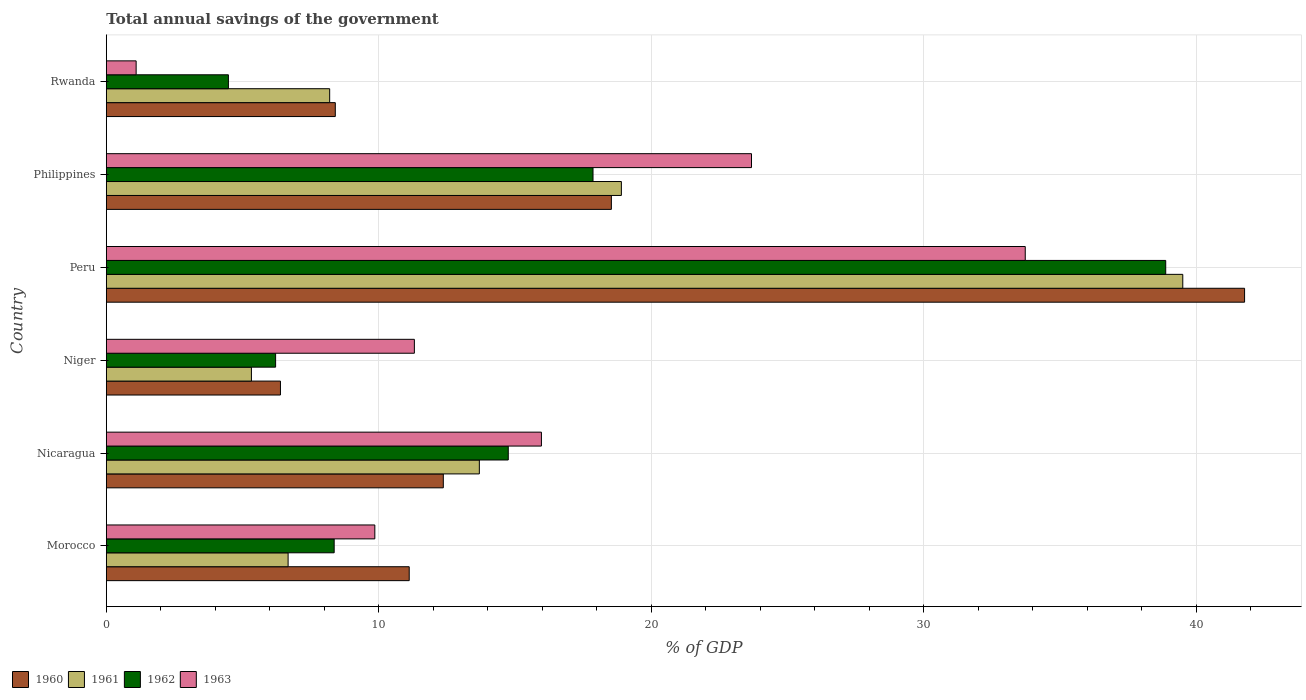How many different coloured bars are there?
Ensure brevity in your answer.  4. How many groups of bars are there?
Ensure brevity in your answer.  6. Are the number of bars per tick equal to the number of legend labels?
Give a very brief answer. Yes. Are the number of bars on each tick of the Y-axis equal?
Make the answer very short. Yes. How many bars are there on the 5th tick from the bottom?
Provide a succinct answer. 4. What is the label of the 5th group of bars from the top?
Your answer should be compact. Nicaragua. What is the total annual savings of the government in 1963 in Philippines?
Ensure brevity in your answer.  23.68. Across all countries, what is the maximum total annual savings of the government in 1960?
Offer a terse response. 41.78. Across all countries, what is the minimum total annual savings of the government in 1960?
Provide a short and direct response. 6.39. In which country was the total annual savings of the government in 1962 maximum?
Ensure brevity in your answer.  Peru. In which country was the total annual savings of the government in 1962 minimum?
Provide a short and direct response. Rwanda. What is the total total annual savings of the government in 1961 in the graph?
Your response must be concise. 92.29. What is the difference between the total annual savings of the government in 1962 in Peru and that in Philippines?
Give a very brief answer. 21.02. What is the difference between the total annual savings of the government in 1960 in Rwanda and the total annual savings of the government in 1963 in Nicaragua?
Provide a succinct answer. -7.56. What is the average total annual savings of the government in 1961 per country?
Your answer should be compact. 15.38. What is the difference between the total annual savings of the government in 1962 and total annual savings of the government in 1963 in Nicaragua?
Offer a very short reply. -1.22. In how many countries, is the total annual savings of the government in 1963 greater than 18 %?
Your response must be concise. 2. What is the ratio of the total annual savings of the government in 1960 in Peru to that in Rwanda?
Provide a succinct answer. 4.97. What is the difference between the highest and the second highest total annual savings of the government in 1960?
Provide a short and direct response. 23.24. What is the difference between the highest and the lowest total annual savings of the government in 1961?
Your answer should be very brief. 34.18. Is the sum of the total annual savings of the government in 1960 in Peru and Philippines greater than the maximum total annual savings of the government in 1962 across all countries?
Your answer should be very brief. Yes. Is it the case that in every country, the sum of the total annual savings of the government in 1962 and total annual savings of the government in 1961 is greater than the sum of total annual savings of the government in 1963 and total annual savings of the government in 1960?
Make the answer very short. No. What does the 3rd bar from the top in Niger represents?
Your answer should be compact. 1961. How many bars are there?
Offer a terse response. 24. How many countries are there in the graph?
Ensure brevity in your answer.  6. What is the difference between two consecutive major ticks on the X-axis?
Keep it short and to the point. 10. Are the values on the major ticks of X-axis written in scientific E-notation?
Give a very brief answer. No. Does the graph contain any zero values?
Make the answer very short. No. Where does the legend appear in the graph?
Offer a terse response. Bottom left. How many legend labels are there?
Keep it short and to the point. 4. How are the legend labels stacked?
Offer a very short reply. Horizontal. What is the title of the graph?
Your answer should be very brief. Total annual savings of the government. What is the label or title of the X-axis?
Provide a succinct answer. % of GDP. What is the % of GDP in 1960 in Morocco?
Give a very brief answer. 11.12. What is the % of GDP in 1961 in Morocco?
Your response must be concise. 6.67. What is the % of GDP of 1962 in Morocco?
Offer a very short reply. 8.36. What is the % of GDP in 1963 in Morocco?
Ensure brevity in your answer.  9.85. What is the % of GDP of 1960 in Nicaragua?
Offer a terse response. 12.37. What is the % of GDP in 1961 in Nicaragua?
Offer a terse response. 13.69. What is the % of GDP in 1962 in Nicaragua?
Your answer should be compact. 14.75. What is the % of GDP in 1963 in Nicaragua?
Ensure brevity in your answer.  15.97. What is the % of GDP in 1960 in Niger?
Provide a succinct answer. 6.39. What is the % of GDP in 1961 in Niger?
Ensure brevity in your answer.  5.32. What is the % of GDP of 1962 in Niger?
Give a very brief answer. 6.21. What is the % of GDP in 1963 in Niger?
Give a very brief answer. 11.31. What is the % of GDP in 1960 in Peru?
Provide a short and direct response. 41.78. What is the % of GDP of 1961 in Peru?
Your answer should be compact. 39.51. What is the % of GDP in 1962 in Peru?
Your answer should be compact. 38.88. What is the % of GDP in 1963 in Peru?
Your answer should be very brief. 33.73. What is the % of GDP in 1960 in Philippines?
Offer a terse response. 18.54. What is the % of GDP in 1961 in Philippines?
Offer a terse response. 18.9. What is the % of GDP of 1962 in Philippines?
Provide a short and direct response. 17.86. What is the % of GDP in 1963 in Philippines?
Provide a succinct answer. 23.68. What is the % of GDP in 1960 in Rwanda?
Your response must be concise. 8.4. What is the % of GDP of 1961 in Rwanda?
Keep it short and to the point. 8.2. What is the % of GDP of 1962 in Rwanda?
Offer a terse response. 4.48. What is the % of GDP of 1963 in Rwanda?
Provide a short and direct response. 1.09. Across all countries, what is the maximum % of GDP in 1960?
Provide a succinct answer. 41.78. Across all countries, what is the maximum % of GDP in 1961?
Provide a short and direct response. 39.51. Across all countries, what is the maximum % of GDP in 1962?
Provide a short and direct response. 38.88. Across all countries, what is the maximum % of GDP in 1963?
Keep it short and to the point. 33.73. Across all countries, what is the minimum % of GDP in 1960?
Your answer should be compact. 6.39. Across all countries, what is the minimum % of GDP in 1961?
Your response must be concise. 5.32. Across all countries, what is the minimum % of GDP in 1962?
Give a very brief answer. 4.48. Across all countries, what is the minimum % of GDP in 1963?
Provide a succinct answer. 1.09. What is the total % of GDP of 1960 in the graph?
Offer a very short reply. 98.59. What is the total % of GDP of 1961 in the graph?
Ensure brevity in your answer.  92.29. What is the total % of GDP of 1962 in the graph?
Provide a succinct answer. 90.55. What is the total % of GDP in 1963 in the graph?
Give a very brief answer. 95.63. What is the difference between the % of GDP of 1960 in Morocco and that in Nicaragua?
Your answer should be compact. -1.25. What is the difference between the % of GDP of 1961 in Morocco and that in Nicaragua?
Give a very brief answer. -7.02. What is the difference between the % of GDP of 1962 in Morocco and that in Nicaragua?
Offer a very short reply. -6.39. What is the difference between the % of GDP of 1963 in Morocco and that in Nicaragua?
Provide a short and direct response. -6.11. What is the difference between the % of GDP in 1960 in Morocco and that in Niger?
Keep it short and to the point. 4.73. What is the difference between the % of GDP in 1961 in Morocco and that in Niger?
Make the answer very short. 1.35. What is the difference between the % of GDP in 1962 in Morocco and that in Niger?
Keep it short and to the point. 2.15. What is the difference between the % of GDP in 1963 in Morocco and that in Niger?
Offer a terse response. -1.45. What is the difference between the % of GDP in 1960 in Morocco and that in Peru?
Make the answer very short. -30.66. What is the difference between the % of GDP in 1961 in Morocco and that in Peru?
Your answer should be compact. -32.84. What is the difference between the % of GDP of 1962 in Morocco and that in Peru?
Provide a succinct answer. -30.52. What is the difference between the % of GDP in 1963 in Morocco and that in Peru?
Keep it short and to the point. -23.87. What is the difference between the % of GDP of 1960 in Morocco and that in Philippines?
Your answer should be very brief. -7.42. What is the difference between the % of GDP of 1961 in Morocco and that in Philippines?
Keep it short and to the point. -12.23. What is the difference between the % of GDP of 1962 in Morocco and that in Philippines?
Ensure brevity in your answer.  -9.5. What is the difference between the % of GDP in 1963 in Morocco and that in Philippines?
Provide a short and direct response. -13.82. What is the difference between the % of GDP of 1960 in Morocco and that in Rwanda?
Your answer should be very brief. 2.71. What is the difference between the % of GDP of 1961 in Morocco and that in Rwanda?
Your answer should be compact. -1.53. What is the difference between the % of GDP of 1962 in Morocco and that in Rwanda?
Make the answer very short. 3.88. What is the difference between the % of GDP in 1963 in Morocco and that in Rwanda?
Make the answer very short. 8.76. What is the difference between the % of GDP in 1960 in Nicaragua and that in Niger?
Make the answer very short. 5.98. What is the difference between the % of GDP in 1961 in Nicaragua and that in Niger?
Your answer should be compact. 8.37. What is the difference between the % of GDP in 1962 in Nicaragua and that in Niger?
Keep it short and to the point. 8.54. What is the difference between the % of GDP in 1963 in Nicaragua and that in Niger?
Make the answer very short. 4.66. What is the difference between the % of GDP in 1960 in Nicaragua and that in Peru?
Provide a succinct answer. -29.41. What is the difference between the % of GDP of 1961 in Nicaragua and that in Peru?
Provide a succinct answer. -25.82. What is the difference between the % of GDP in 1962 in Nicaragua and that in Peru?
Provide a succinct answer. -24.13. What is the difference between the % of GDP in 1963 in Nicaragua and that in Peru?
Give a very brief answer. -17.76. What is the difference between the % of GDP in 1960 in Nicaragua and that in Philippines?
Give a very brief answer. -6.17. What is the difference between the % of GDP of 1961 in Nicaragua and that in Philippines?
Provide a succinct answer. -5.21. What is the difference between the % of GDP in 1962 in Nicaragua and that in Philippines?
Your answer should be compact. -3.11. What is the difference between the % of GDP of 1963 in Nicaragua and that in Philippines?
Keep it short and to the point. -7.71. What is the difference between the % of GDP of 1960 in Nicaragua and that in Rwanda?
Your response must be concise. 3.96. What is the difference between the % of GDP in 1961 in Nicaragua and that in Rwanda?
Ensure brevity in your answer.  5.49. What is the difference between the % of GDP in 1962 in Nicaragua and that in Rwanda?
Provide a short and direct response. 10.27. What is the difference between the % of GDP of 1963 in Nicaragua and that in Rwanda?
Your answer should be very brief. 14.87. What is the difference between the % of GDP of 1960 in Niger and that in Peru?
Make the answer very short. -35.38. What is the difference between the % of GDP of 1961 in Niger and that in Peru?
Your answer should be compact. -34.18. What is the difference between the % of GDP in 1962 in Niger and that in Peru?
Your answer should be very brief. -32.67. What is the difference between the % of GDP of 1963 in Niger and that in Peru?
Keep it short and to the point. -22.42. What is the difference between the % of GDP of 1960 in Niger and that in Philippines?
Keep it short and to the point. -12.15. What is the difference between the % of GDP of 1961 in Niger and that in Philippines?
Provide a succinct answer. -13.58. What is the difference between the % of GDP of 1962 in Niger and that in Philippines?
Provide a short and direct response. -11.65. What is the difference between the % of GDP in 1963 in Niger and that in Philippines?
Offer a very short reply. -12.37. What is the difference between the % of GDP in 1960 in Niger and that in Rwanda?
Ensure brevity in your answer.  -2.01. What is the difference between the % of GDP of 1961 in Niger and that in Rwanda?
Offer a terse response. -2.87. What is the difference between the % of GDP of 1962 in Niger and that in Rwanda?
Provide a short and direct response. 1.73. What is the difference between the % of GDP of 1963 in Niger and that in Rwanda?
Provide a short and direct response. 10.21. What is the difference between the % of GDP in 1960 in Peru and that in Philippines?
Offer a terse response. 23.24. What is the difference between the % of GDP of 1961 in Peru and that in Philippines?
Your response must be concise. 20.6. What is the difference between the % of GDP in 1962 in Peru and that in Philippines?
Keep it short and to the point. 21.02. What is the difference between the % of GDP of 1963 in Peru and that in Philippines?
Your answer should be compact. 10.05. What is the difference between the % of GDP in 1960 in Peru and that in Rwanda?
Make the answer very short. 33.37. What is the difference between the % of GDP in 1961 in Peru and that in Rwanda?
Give a very brief answer. 31.31. What is the difference between the % of GDP in 1962 in Peru and that in Rwanda?
Provide a succinct answer. 34.4. What is the difference between the % of GDP of 1963 in Peru and that in Rwanda?
Provide a short and direct response. 32.63. What is the difference between the % of GDP in 1960 in Philippines and that in Rwanda?
Your answer should be compact. 10.13. What is the difference between the % of GDP of 1961 in Philippines and that in Rwanda?
Make the answer very short. 10.71. What is the difference between the % of GDP in 1962 in Philippines and that in Rwanda?
Your answer should be very brief. 13.38. What is the difference between the % of GDP of 1963 in Philippines and that in Rwanda?
Your response must be concise. 22.58. What is the difference between the % of GDP of 1960 in Morocco and the % of GDP of 1961 in Nicaragua?
Your answer should be compact. -2.57. What is the difference between the % of GDP of 1960 in Morocco and the % of GDP of 1962 in Nicaragua?
Offer a very short reply. -3.63. What is the difference between the % of GDP of 1960 in Morocco and the % of GDP of 1963 in Nicaragua?
Ensure brevity in your answer.  -4.85. What is the difference between the % of GDP of 1961 in Morocco and the % of GDP of 1962 in Nicaragua?
Ensure brevity in your answer.  -8.08. What is the difference between the % of GDP in 1961 in Morocco and the % of GDP in 1963 in Nicaragua?
Ensure brevity in your answer.  -9.3. What is the difference between the % of GDP in 1962 in Morocco and the % of GDP in 1963 in Nicaragua?
Keep it short and to the point. -7.61. What is the difference between the % of GDP of 1960 in Morocco and the % of GDP of 1961 in Niger?
Provide a succinct answer. 5.79. What is the difference between the % of GDP in 1960 in Morocco and the % of GDP in 1962 in Niger?
Give a very brief answer. 4.9. What is the difference between the % of GDP in 1960 in Morocco and the % of GDP in 1963 in Niger?
Ensure brevity in your answer.  -0.19. What is the difference between the % of GDP in 1961 in Morocco and the % of GDP in 1962 in Niger?
Your response must be concise. 0.46. What is the difference between the % of GDP in 1961 in Morocco and the % of GDP in 1963 in Niger?
Provide a short and direct response. -4.63. What is the difference between the % of GDP in 1962 in Morocco and the % of GDP in 1963 in Niger?
Provide a succinct answer. -2.94. What is the difference between the % of GDP in 1960 in Morocco and the % of GDP in 1961 in Peru?
Offer a terse response. -28.39. What is the difference between the % of GDP of 1960 in Morocco and the % of GDP of 1962 in Peru?
Provide a succinct answer. -27.76. What is the difference between the % of GDP in 1960 in Morocco and the % of GDP in 1963 in Peru?
Your response must be concise. -22.61. What is the difference between the % of GDP in 1961 in Morocco and the % of GDP in 1962 in Peru?
Offer a terse response. -32.21. What is the difference between the % of GDP of 1961 in Morocco and the % of GDP of 1963 in Peru?
Your response must be concise. -27.05. What is the difference between the % of GDP in 1962 in Morocco and the % of GDP in 1963 in Peru?
Make the answer very short. -25.36. What is the difference between the % of GDP of 1960 in Morocco and the % of GDP of 1961 in Philippines?
Offer a terse response. -7.79. What is the difference between the % of GDP of 1960 in Morocco and the % of GDP of 1962 in Philippines?
Give a very brief answer. -6.75. What is the difference between the % of GDP of 1960 in Morocco and the % of GDP of 1963 in Philippines?
Give a very brief answer. -12.56. What is the difference between the % of GDP in 1961 in Morocco and the % of GDP in 1962 in Philippines?
Ensure brevity in your answer.  -11.19. What is the difference between the % of GDP of 1961 in Morocco and the % of GDP of 1963 in Philippines?
Provide a succinct answer. -17.01. What is the difference between the % of GDP in 1962 in Morocco and the % of GDP in 1963 in Philippines?
Make the answer very short. -15.32. What is the difference between the % of GDP in 1960 in Morocco and the % of GDP in 1961 in Rwanda?
Ensure brevity in your answer.  2.92. What is the difference between the % of GDP in 1960 in Morocco and the % of GDP in 1962 in Rwanda?
Keep it short and to the point. 6.64. What is the difference between the % of GDP of 1960 in Morocco and the % of GDP of 1963 in Rwanda?
Your answer should be very brief. 10.02. What is the difference between the % of GDP in 1961 in Morocco and the % of GDP in 1962 in Rwanda?
Offer a very short reply. 2.19. What is the difference between the % of GDP of 1961 in Morocco and the % of GDP of 1963 in Rwanda?
Provide a succinct answer. 5.58. What is the difference between the % of GDP in 1962 in Morocco and the % of GDP in 1963 in Rwanda?
Offer a terse response. 7.27. What is the difference between the % of GDP in 1960 in Nicaragua and the % of GDP in 1961 in Niger?
Provide a succinct answer. 7.04. What is the difference between the % of GDP of 1960 in Nicaragua and the % of GDP of 1962 in Niger?
Ensure brevity in your answer.  6.16. What is the difference between the % of GDP of 1960 in Nicaragua and the % of GDP of 1963 in Niger?
Offer a very short reply. 1.06. What is the difference between the % of GDP in 1961 in Nicaragua and the % of GDP in 1962 in Niger?
Your answer should be compact. 7.48. What is the difference between the % of GDP of 1961 in Nicaragua and the % of GDP of 1963 in Niger?
Give a very brief answer. 2.38. What is the difference between the % of GDP in 1962 in Nicaragua and the % of GDP in 1963 in Niger?
Provide a short and direct response. 3.45. What is the difference between the % of GDP of 1960 in Nicaragua and the % of GDP of 1961 in Peru?
Offer a very short reply. -27.14. What is the difference between the % of GDP of 1960 in Nicaragua and the % of GDP of 1962 in Peru?
Ensure brevity in your answer.  -26.51. What is the difference between the % of GDP of 1960 in Nicaragua and the % of GDP of 1963 in Peru?
Provide a succinct answer. -21.36. What is the difference between the % of GDP in 1961 in Nicaragua and the % of GDP in 1962 in Peru?
Make the answer very short. -25.19. What is the difference between the % of GDP of 1961 in Nicaragua and the % of GDP of 1963 in Peru?
Offer a very short reply. -20.04. What is the difference between the % of GDP of 1962 in Nicaragua and the % of GDP of 1963 in Peru?
Your answer should be compact. -18.97. What is the difference between the % of GDP in 1960 in Nicaragua and the % of GDP in 1961 in Philippines?
Your response must be concise. -6.54. What is the difference between the % of GDP in 1960 in Nicaragua and the % of GDP in 1962 in Philippines?
Your answer should be compact. -5.49. What is the difference between the % of GDP of 1960 in Nicaragua and the % of GDP of 1963 in Philippines?
Make the answer very short. -11.31. What is the difference between the % of GDP in 1961 in Nicaragua and the % of GDP in 1962 in Philippines?
Keep it short and to the point. -4.17. What is the difference between the % of GDP of 1961 in Nicaragua and the % of GDP of 1963 in Philippines?
Your answer should be compact. -9.99. What is the difference between the % of GDP in 1962 in Nicaragua and the % of GDP in 1963 in Philippines?
Offer a very short reply. -8.93. What is the difference between the % of GDP in 1960 in Nicaragua and the % of GDP in 1961 in Rwanda?
Make the answer very short. 4.17. What is the difference between the % of GDP of 1960 in Nicaragua and the % of GDP of 1962 in Rwanda?
Make the answer very short. 7.89. What is the difference between the % of GDP of 1960 in Nicaragua and the % of GDP of 1963 in Rwanda?
Provide a short and direct response. 11.27. What is the difference between the % of GDP in 1961 in Nicaragua and the % of GDP in 1962 in Rwanda?
Your answer should be very brief. 9.21. What is the difference between the % of GDP of 1961 in Nicaragua and the % of GDP of 1963 in Rwanda?
Offer a terse response. 12.6. What is the difference between the % of GDP in 1962 in Nicaragua and the % of GDP in 1963 in Rwanda?
Your answer should be very brief. 13.66. What is the difference between the % of GDP of 1960 in Niger and the % of GDP of 1961 in Peru?
Your answer should be very brief. -33.12. What is the difference between the % of GDP in 1960 in Niger and the % of GDP in 1962 in Peru?
Offer a very short reply. -32.49. What is the difference between the % of GDP in 1960 in Niger and the % of GDP in 1963 in Peru?
Make the answer very short. -27.33. What is the difference between the % of GDP in 1961 in Niger and the % of GDP in 1962 in Peru?
Make the answer very short. -33.56. What is the difference between the % of GDP of 1961 in Niger and the % of GDP of 1963 in Peru?
Your response must be concise. -28.4. What is the difference between the % of GDP in 1962 in Niger and the % of GDP in 1963 in Peru?
Give a very brief answer. -27.51. What is the difference between the % of GDP in 1960 in Niger and the % of GDP in 1961 in Philippines?
Offer a terse response. -12.51. What is the difference between the % of GDP of 1960 in Niger and the % of GDP of 1962 in Philippines?
Offer a terse response. -11.47. What is the difference between the % of GDP of 1960 in Niger and the % of GDP of 1963 in Philippines?
Your answer should be very brief. -17.29. What is the difference between the % of GDP in 1961 in Niger and the % of GDP in 1962 in Philippines?
Your answer should be very brief. -12.54. What is the difference between the % of GDP of 1961 in Niger and the % of GDP of 1963 in Philippines?
Provide a short and direct response. -18.35. What is the difference between the % of GDP of 1962 in Niger and the % of GDP of 1963 in Philippines?
Provide a succinct answer. -17.47. What is the difference between the % of GDP of 1960 in Niger and the % of GDP of 1961 in Rwanda?
Make the answer very short. -1.81. What is the difference between the % of GDP in 1960 in Niger and the % of GDP in 1962 in Rwanda?
Offer a very short reply. 1.91. What is the difference between the % of GDP in 1960 in Niger and the % of GDP in 1963 in Rwanda?
Provide a succinct answer. 5.3. What is the difference between the % of GDP of 1961 in Niger and the % of GDP of 1962 in Rwanda?
Your response must be concise. 0.84. What is the difference between the % of GDP of 1961 in Niger and the % of GDP of 1963 in Rwanda?
Your answer should be very brief. 4.23. What is the difference between the % of GDP in 1962 in Niger and the % of GDP in 1963 in Rwanda?
Keep it short and to the point. 5.12. What is the difference between the % of GDP of 1960 in Peru and the % of GDP of 1961 in Philippines?
Keep it short and to the point. 22.87. What is the difference between the % of GDP of 1960 in Peru and the % of GDP of 1962 in Philippines?
Provide a short and direct response. 23.91. What is the difference between the % of GDP in 1960 in Peru and the % of GDP in 1963 in Philippines?
Give a very brief answer. 18.1. What is the difference between the % of GDP of 1961 in Peru and the % of GDP of 1962 in Philippines?
Your answer should be compact. 21.65. What is the difference between the % of GDP of 1961 in Peru and the % of GDP of 1963 in Philippines?
Ensure brevity in your answer.  15.83. What is the difference between the % of GDP of 1962 in Peru and the % of GDP of 1963 in Philippines?
Offer a very short reply. 15.2. What is the difference between the % of GDP of 1960 in Peru and the % of GDP of 1961 in Rwanda?
Make the answer very short. 33.58. What is the difference between the % of GDP of 1960 in Peru and the % of GDP of 1962 in Rwanda?
Your answer should be very brief. 37.3. What is the difference between the % of GDP of 1960 in Peru and the % of GDP of 1963 in Rwanda?
Your answer should be compact. 40.68. What is the difference between the % of GDP of 1961 in Peru and the % of GDP of 1962 in Rwanda?
Ensure brevity in your answer.  35.03. What is the difference between the % of GDP of 1961 in Peru and the % of GDP of 1963 in Rwanda?
Offer a terse response. 38.41. What is the difference between the % of GDP in 1962 in Peru and the % of GDP in 1963 in Rwanda?
Keep it short and to the point. 37.79. What is the difference between the % of GDP in 1960 in Philippines and the % of GDP in 1961 in Rwanda?
Provide a short and direct response. 10.34. What is the difference between the % of GDP of 1960 in Philippines and the % of GDP of 1962 in Rwanda?
Your answer should be very brief. 14.06. What is the difference between the % of GDP in 1960 in Philippines and the % of GDP in 1963 in Rwanda?
Make the answer very short. 17.44. What is the difference between the % of GDP in 1961 in Philippines and the % of GDP in 1962 in Rwanda?
Give a very brief answer. 14.42. What is the difference between the % of GDP of 1961 in Philippines and the % of GDP of 1963 in Rwanda?
Provide a short and direct response. 17.81. What is the difference between the % of GDP of 1962 in Philippines and the % of GDP of 1963 in Rwanda?
Your answer should be very brief. 16.77. What is the average % of GDP of 1960 per country?
Your answer should be very brief. 16.43. What is the average % of GDP of 1961 per country?
Provide a succinct answer. 15.38. What is the average % of GDP in 1962 per country?
Ensure brevity in your answer.  15.09. What is the average % of GDP in 1963 per country?
Your response must be concise. 15.94. What is the difference between the % of GDP in 1960 and % of GDP in 1961 in Morocco?
Your answer should be very brief. 4.45. What is the difference between the % of GDP of 1960 and % of GDP of 1962 in Morocco?
Provide a succinct answer. 2.75. What is the difference between the % of GDP in 1960 and % of GDP in 1963 in Morocco?
Provide a succinct answer. 1.26. What is the difference between the % of GDP in 1961 and % of GDP in 1962 in Morocco?
Provide a short and direct response. -1.69. What is the difference between the % of GDP of 1961 and % of GDP of 1963 in Morocco?
Keep it short and to the point. -3.18. What is the difference between the % of GDP in 1962 and % of GDP in 1963 in Morocco?
Provide a short and direct response. -1.49. What is the difference between the % of GDP in 1960 and % of GDP in 1961 in Nicaragua?
Offer a terse response. -1.32. What is the difference between the % of GDP of 1960 and % of GDP of 1962 in Nicaragua?
Provide a succinct answer. -2.38. What is the difference between the % of GDP in 1960 and % of GDP in 1963 in Nicaragua?
Give a very brief answer. -3.6. What is the difference between the % of GDP of 1961 and % of GDP of 1962 in Nicaragua?
Keep it short and to the point. -1.06. What is the difference between the % of GDP in 1961 and % of GDP in 1963 in Nicaragua?
Provide a short and direct response. -2.28. What is the difference between the % of GDP in 1962 and % of GDP in 1963 in Nicaragua?
Keep it short and to the point. -1.22. What is the difference between the % of GDP in 1960 and % of GDP in 1961 in Niger?
Offer a very short reply. 1.07. What is the difference between the % of GDP of 1960 and % of GDP of 1962 in Niger?
Keep it short and to the point. 0.18. What is the difference between the % of GDP in 1960 and % of GDP in 1963 in Niger?
Your answer should be very brief. -4.91. What is the difference between the % of GDP of 1961 and % of GDP of 1962 in Niger?
Offer a very short reply. -0.89. What is the difference between the % of GDP of 1961 and % of GDP of 1963 in Niger?
Your answer should be compact. -5.98. What is the difference between the % of GDP of 1962 and % of GDP of 1963 in Niger?
Provide a short and direct response. -5.09. What is the difference between the % of GDP of 1960 and % of GDP of 1961 in Peru?
Keep it short and to the point. 2.27. What is the difference between the % of GDP in 1960 and % of GDP in 1962 in Peru?
Offer a terse response. 2.89. What is the difference between the % of GDP of 1960 and % of GDP of 1963 in Peru?
Keep it short and to the point. 8.05. What is the difference between the % of GDP of 1961 and % of GDP of 1962 in Peru?
Provide a succinct answer. 0.63. What is the difference between the % of GDP of 1961 and % of GDP of 1963 in Peru?
Keep it short and to the point. 5.78. What is the difference between the % of GDP in 1962 and % of GDP in 1963 in Peru?
Your answer should be compact. 5.16. What is the difference between the % of GDP in 1960 and % of GDP in 1961 in Philippines?
Give a very brief answer. -0.37. What is the difference between the % of GDP of 1960 and % of GDP of 1962 in Philippines?
Your response must be concise. 0.67. What is the difference between the % of GDP of 1960 and % of GDP of 1963 in Philippines?
Your response must be concise. -5.14. What is the difference between the % of GDP of 1961 and % of GDP of 1962 in Philippines?
Make the answer very short. 1.04. What is the difference between the % of GDP of 1961 and % of GDP of 1963 in Philippines?
Give a very brief answer. -4.78. What is the difference between the % of GDP of 1962 and % of GDP of 1963 in Philippines?
Your response must be concise. -5.82. What is the difference between the % of GDP in 1960 and % of GDP in 1961 in Rwanda?
Ensure brevity in your answer.  0.21. What is the difference between the % of GDP of 1960 and % of GDP of 1962 in Rwanda?
Your answer should be compact. 3.92. What is the difference between the % of GDP in 1960 and % of GDP in 1963 in Rwanda?
Provide a short and direct response. 7.31. What is the difference between the % of GDP of 1961 and % of GDP of 1962 in Rwanda?
Offer a very short reply. 3.72. What is the difference between the % of GDP in 1961 and % of GDP in 1963 in Rwanda?
Provide a succinct answer. 7.1. What is the difference between the % of GDP of 1962 and % of GDP of 1963 in Rwanda?
Make the answer very short. 3.39. What is the ratio of the % of GDP in 1960 in Morocco to that in Nicaragua?
Provide a succinct answer. 0.9. What is the ratio of the % of GDP in 1961 in Morocco to that in Nicaragua?
Provide a succinct answer. 0.49. What is the ratio of the % of GDP of 1962 in Morocco to that in Nicaragua?
Give a very brief answer. 0.57. What is the ratio of the % of GDP of 1963 in Morocco to that in Nicaragua?
Provide a short and direct response. 0.62. What is the ratio of the % of GDP in 1960 in Morocco to that in Niger?
Give a very brief answer. 1.74. What is the ratio of the % of GDP of 1961 in Morocco to that in Niger?
Your answer should be very brief. 1.25. What is the ratio of the % of GDP in 1962 in Morocco to that in Niger?
Provide a succinct answer. 1.35. What is the ratio of the % of GDP in 1963 in Morocco to that in Niger?
Make the answer very short. 0.87. What is the ratio of the % of GDP of 1960 in Morocco to that in Peru?
Ensure brevity in your answer.  0.27. What is the ratio of the % of GDP of 1961 in Morocco to that in Peru?
Make the answer very short. 0.17. What is the ratio of the % of GDP of 1962 in Morocco to that in Peru?
Offer a terse response. 0.22. What is the ratio of the % of GDP in 1963 in Morocco to that in Peru?
Your answer should be very brief. 0.29. What is the ratio of the % of GDP in 1960 in Morocco to that in Philippines?
Make the answer very short. 0.6. What is the ratio of the % of GDP of 1961 in Morocco to that in Philippines?
Make the answer very short. 0.35. What is the ratio of the % of GDP in 1962 in Morocco to that in Philippines?
Provide a short and direct response. 0.47. What is the ratio of the % of GDP in 1963 in Morocco to that in Philippines?
Your response must be concise. 0.42. What is the ratio of the % of GDP of 1960 in Morocco to that in Rwanda?
Ensure brevity in your answer.  1.32. What is the ratio of the % of GDP in 1961 in Morocco to that in Rwanda?
Ensure brevity in your answer.  0.81. What is the ratio of the % of GDP of 1962 in Morocco to that in Rwanda?
Provide a succinct answer. 1.87. What is the ratio of the % of GDP of 1963 in Morocco to that in Rwanda?
Offer a terse response. 9.01. What is the ratio of the % of GDP in 1960 in Nicaragua to that in Niger?
Give a very brief answer. 1.94. What is the ratio of the % of GDP in 1961 in Nicaragua to that in Niger?
Your answer should be very brief. 2.57. What is the ratio of the % of GDP in 1962 in Nicaragua to that in Niger?
Keep it short and to the point. 2.37. What is the ratio of the % of GDP in 1963 in Nicaragua to that in Niger?
Make the answer very short. 1.41. What is the ratio of the % of GDP in 1960 in Nicaragua to that in Peru?
Ensure brevity in your answer.  0.3. What is the ratio of the % of GDP in 1961 in Nicaragua to that in Peru?
Give a very brief answer. 0.35. What is the ratio of the % of GDP in 1962 in Nicaragua to that in Peru?
Offer a terse response. 0.38. What is the ratio of the % of GDP in 1963 in Nicaragua to that in Peru?
Offer a very short reply. 0.47. What is the ratio of the % of GDP in 1960 in Nicaragua to that in Philippines?
Offer a very short reply. 0.67. What is the ratio of the % of GDP in 1961 in Nicaragua to that in Philippines?
Your answer should be very brief. 0.72. What is the ratio of the % of GDP in 1962 in Nicaragua to that in Philippines?
Your answer should be very brief. 0.83. What is the ratio of the % of GDP of 1963 in Nicaragua to that in Philippines?
Ensure brevity in your answer.  0.67. What is the ratio of the % of GDP of 1960 in Nicaragua to that in Rwanda?
Ensure brevity in your answer.  1.47. What is the ratio of the % of GDP in 1961 in Nicaragua to that in Rwanda?
Provide a succinct answer. 1.67. What is the ratio of the % of GDP of 1962 in Nicaragua to that in Rwanda?
Your response must be concise. 3.29. What is the ratio of the % of GDP of 1963 in Nicaragua to that in Rwanda?
Offer a very short reply. 14.6. What is the ratio of the % of GDP of 1960 in Niger to that in Peru?
Give a very brief answer. 0.15. What is the ratio of the % of GDP in 1961 in Niger to that in Peru?
Ensure brevity in your answer.  0.13. What is the ratio of the % of GDP of 1962 in Niger to that in Peru?
Keep it short and to the point. 0.16. What is the ratio of the % of GDP in 1963 in Niger to that in Peru?
Ensure brevity in your answer.  0.34. What is the ratio of the % of GDP of 1960 in Niger to that in Philippines?
Ensure brevity in your answer.  0.34. What is the ratio of the % of GDP of 1961 in Niger to that in Philippines?
Provide a succinct answer. 0.28. What is the ratio of the % of GDP of 1962 in Niger to that in Philippines?
Offer a terse response. 0.35. What is the ratio of the % of GDP of 1963 in Niger to that in Philippines?
Ensure brevity in your answer.  0.48. What is the ratio of the % of GDP in 1960 in Niger to that in Rwanda?
Offer a very short reply. 0.76. What is the ratio of the % of GDP of 1961 in Niger to that in Rwanda?
Your answer should be compact. 0.65. What is the ratio of the % of GDP of 1962 in Niger to that in Rwanda?
Your answer should be very brief. 1.39. What is the ratio of the % of GDP in 1963 in Niger to that in Rwanda?
Your response must be concise. 10.34. What is the ratio of the % of GDP in 1960 in Peru to that in Philippines?
Ensure brevity in your answer.  2.25. What is the ratio of the % of GDP in 1961 in Peru to that in Philippines?
Your answer should be very brief. 2.09. What is the ratio of the % of GDP of 1962 in Peru to that in Philippines?
Give a very brief answer. 2.18. What is the ratio of the % of GDP in 1963 in Peru to that in Philippines?
Ensure brevity in your answer.  1.42. What is the ratio of the % of GDP in 1960 in Peru to that in Rwanda?
Give a very brief answer. 4.97. What is the ratio of the % of GDP of 1961 in Peru to that in Rwanda?
Your answer should be very brief. 4.82. What is the ratio of the % of GDP in 1962 in Peru to that in Rwanda?
Give a very brief answer. 8.68. What is the ratio of the % of GDP of 1963 in Peru to that in Rwanda?
Offer a very short reply. 30.83. What is the ratio of the % of GDP of 1960 in Philippines to that in Rwanda?
Your response must be concise. 2.21. What is the ratio of the % of GDP of 1961 in Philippines to that in Rwanda?
Give a very brief answer. 2.31. What is the ratio of the % of GDP of 1962 in Philippines to that in Rwanda?
Make the answer very short. 3.99. What is the ratio of the % of GDP of 1963 in Philippines to that in Rwanda?
Provide a succinct answer. 21.65. What is the difference between the highest and the second highest % of GDP in 1960?
Make the answer very short. 23.24. What is the difference between the highest and the second highest % of GDP in 1961?
Offer a very short reply. 20.6. What is the difference between the highest and the second highest % of GDP in 1962?
Provide a short and direct response. 21.02. What is the difference between the highest and the second highest % of GDP in 1963?
Your response must be concise. 10.05. What is the difference between the highest and the lowest % of GDP in 1960?
Offer a terse response. 35.38. What is the difference between the highest and the lowest % of GDP of 1961?
Ensure brevity in your answer.  34.18. What is the difference between the highest and the lowest % of GDP of 1962?
Provide a succinct answer. 34.4. What is the difference between the highest and the lowest % of GDP in 1963?
Your answer should be very brief. 32.63. 